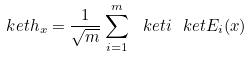Convert formula to latex. <formula><loc_0><loc_0><loc_500><loc_500>\ k e t { h _ { x } } = { \frac { 1 } { \sqrt { m } } } \sum _ { i = 1 } ^ { m } \ k e t { i } \ k e t { E _ { i } ( x ) }</formula> 